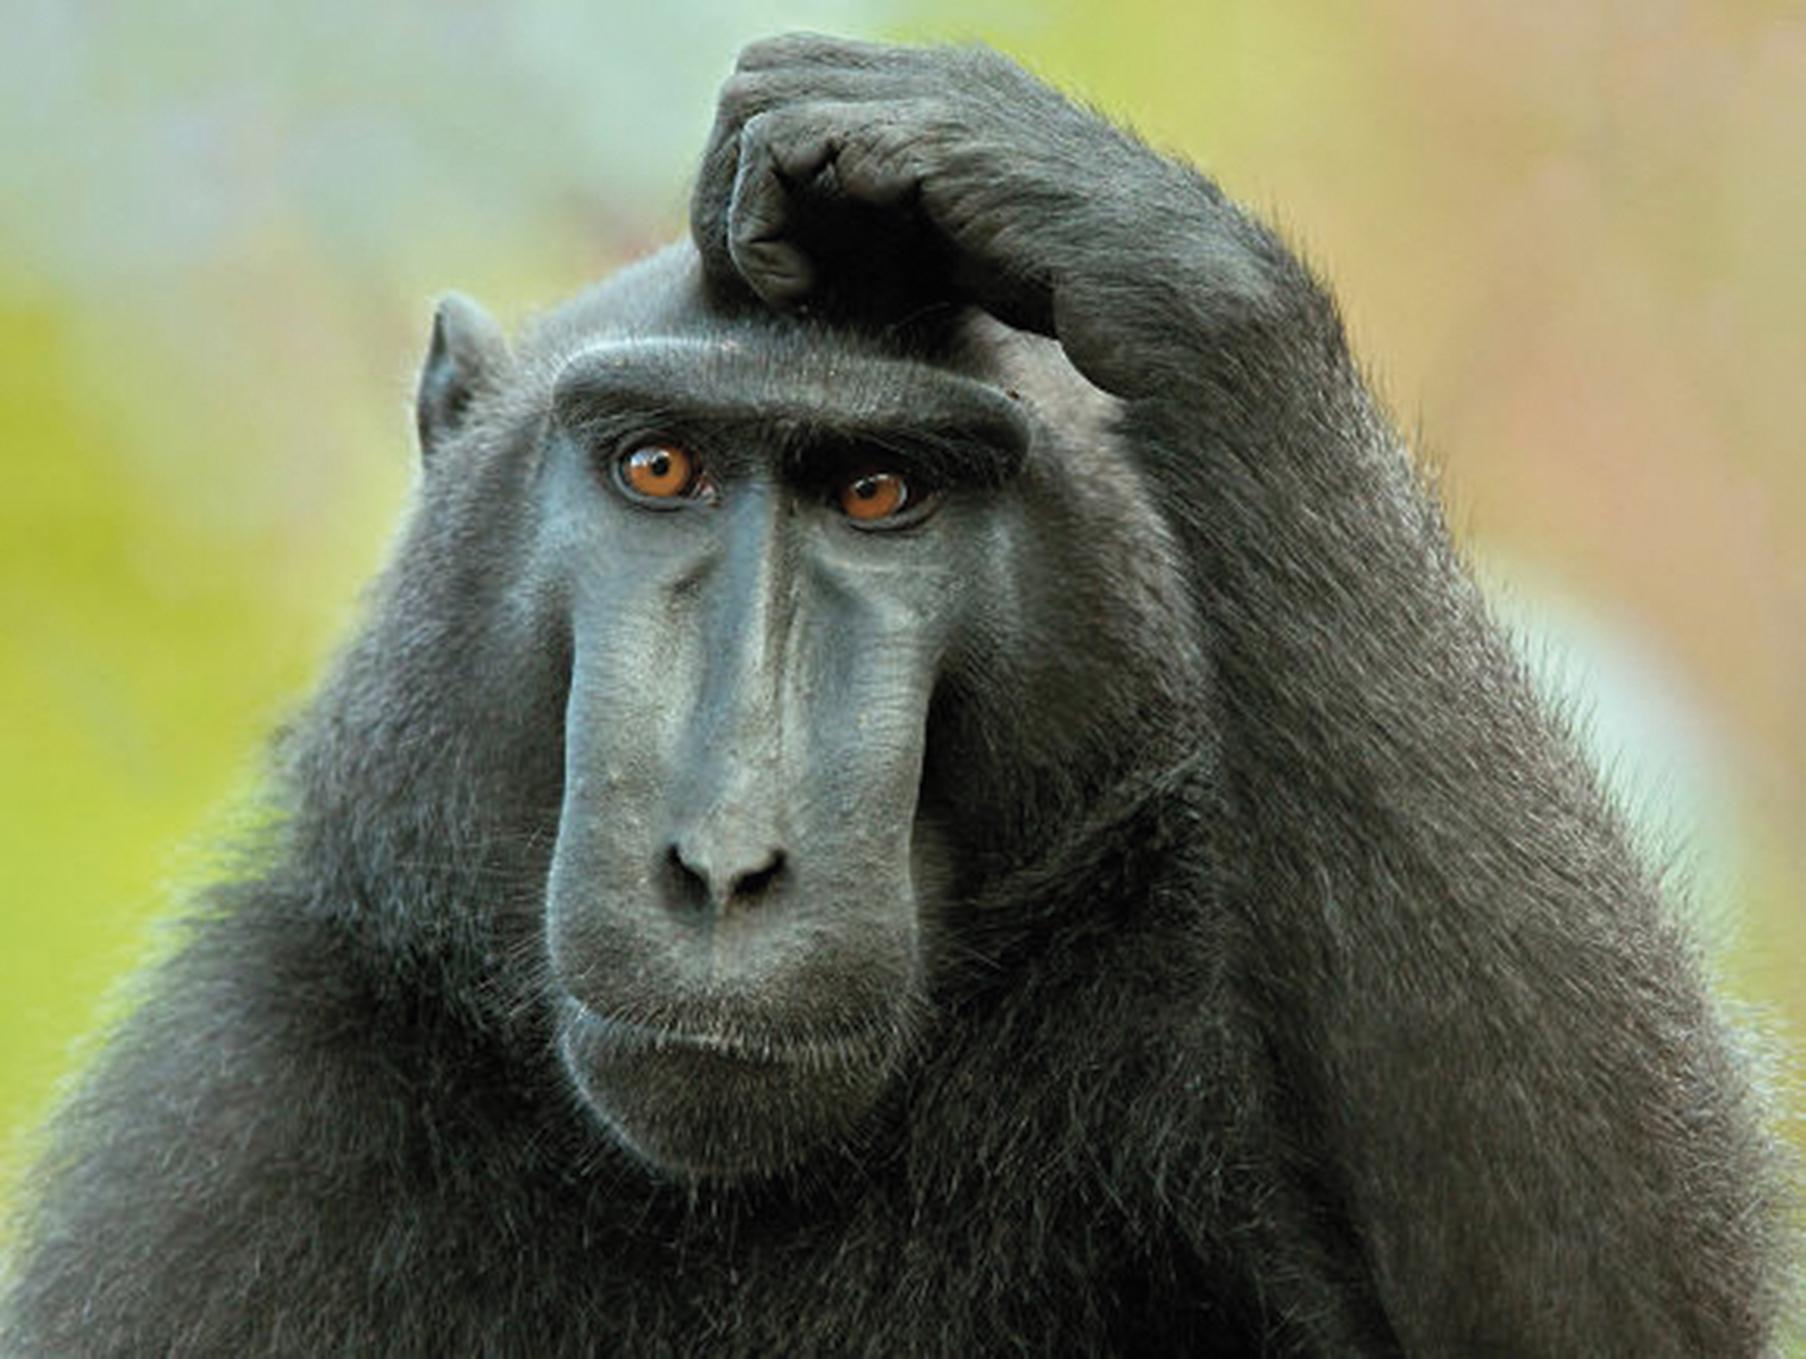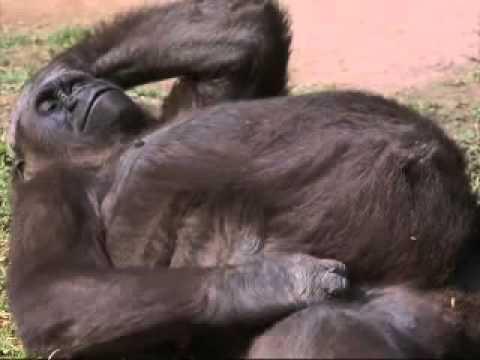The first image is the image on the left, the second image is the image on the right. For the images displayed, is the sentence "At least one ape is showing its teeth." factually correct? Answer yes or no. No. 